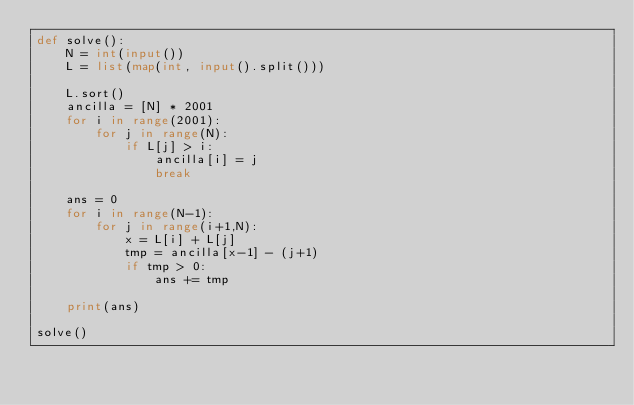<code> <loc_0><loc_0><loc_500><loc_500><_Python_>def solve():
    N = int(input())
    L = list(map(int, input().split()))

    L.sort()
    ancilla = [N] * 2001
    for i in range(2001):
        for j in range(N):
            if L[j] > i:
                ancilla[i] = j
                break

    ans = 0
    for i in range(N-1):
        for j in range(i+1,N):
            x = L[i] + L[j]
            tmp = ancilla[x-1] - (j+1)
            if tmp > 0:
                ans += tmp

    print(ans)

solve()</code> 